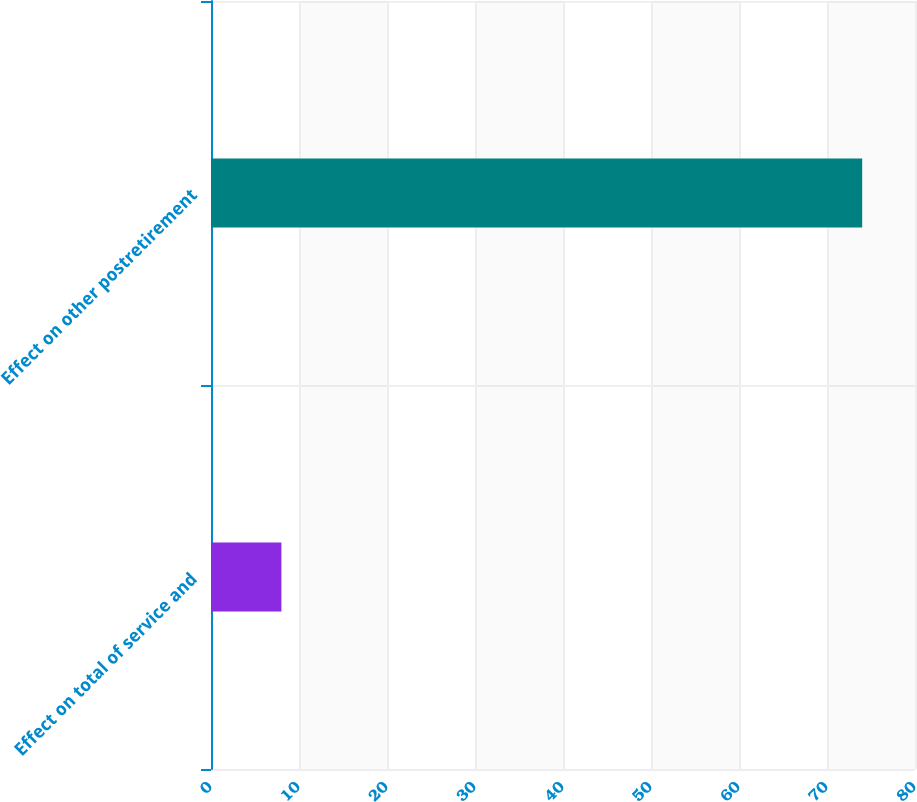Convert chart. <chart><loc_0><loc_0><loc_500><loc_500><bar_chart><fcel>Effect on total of service and<fcel>Effect on other postretirement<nl><fcel>8<fcel>74<nl></chart> 